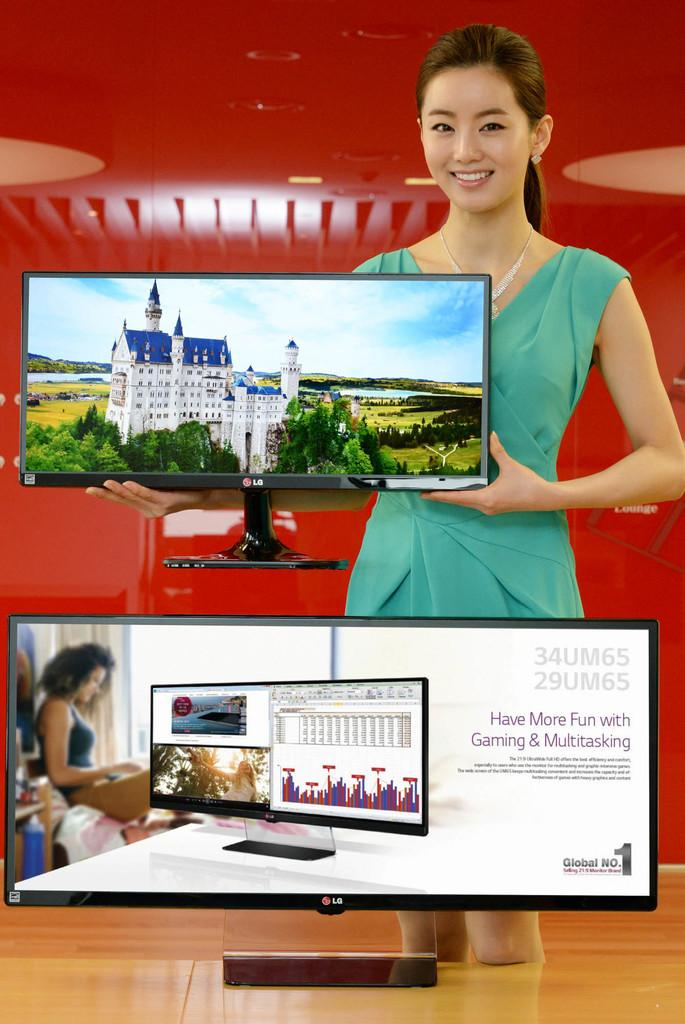<image>
Provide a brief description of the given image. Advertisement for LG televisions using an Asian model to showcase them. 